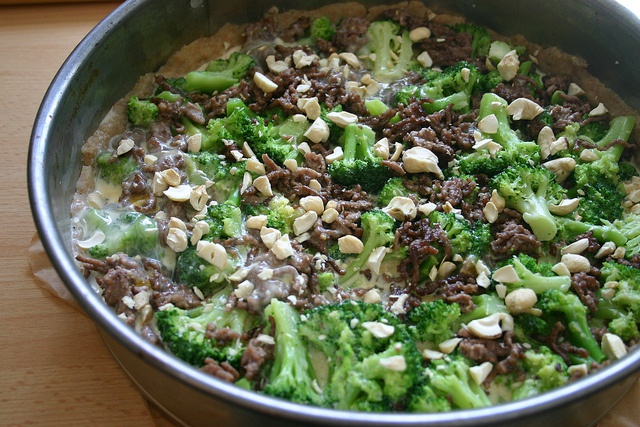Describe the objects in this image and their specific colors. I can see bowl in black, maroon, darkgreen, gray, and darkgray tones, broccoli in maroon, black, darkgreen, and gray tones, broccoli in maroon, green, black, and darkgreen tones, broccoli in maroon, darkgreen, green, and lightgreen tones, and broccoli in maroon, black, darkgreen, and darkgray tones in this image. 